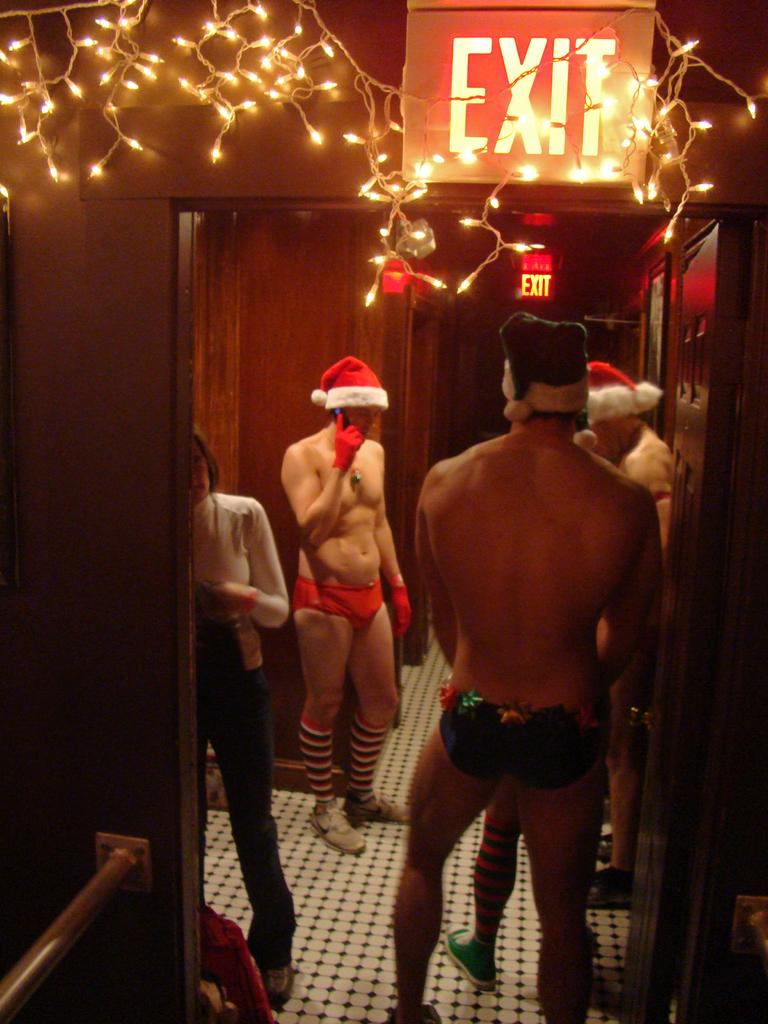What is happening in the image? There are people standing in the image. What can be seen on the wall in the image? There is an exit board in the image. What can be seen illuminating the area in the image? There are lights visible in the image. What type of structure is present in the image? There is a wall in the image. What type of pain is the person experiencing in the image? There is no indication of pain or any person experiencing pain in the image. 